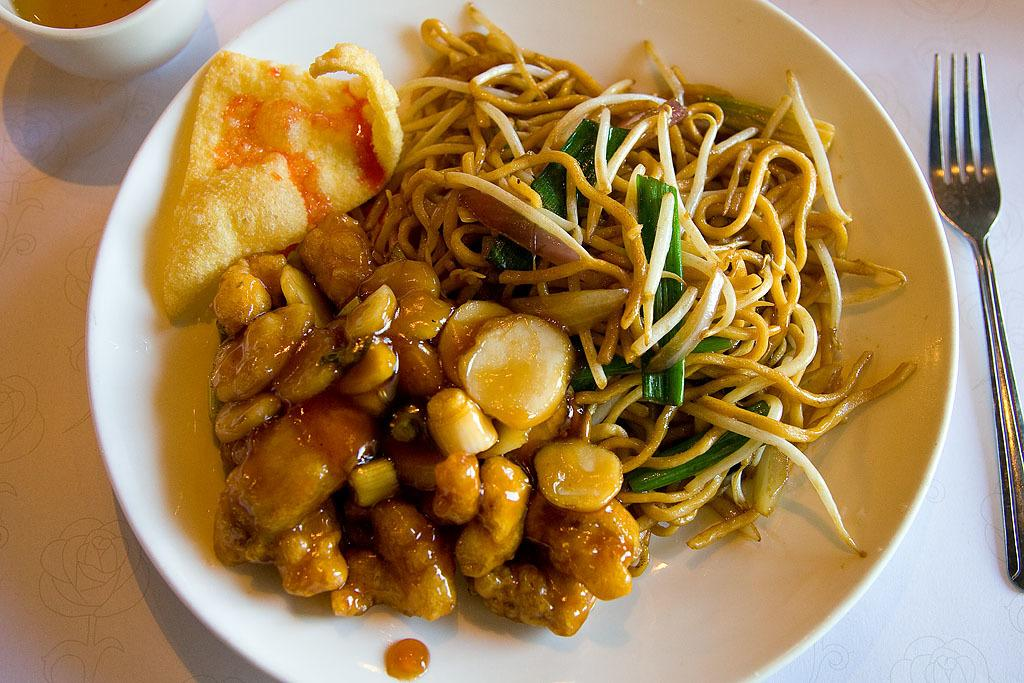What type of food is on the plate in the image? There is a chip, noodles, vegetable pieces, and curry on the plate. What color is the plate in the image? The plate is white in color. What utensil is present on the plate? There is a fork on the plate. What beverage is visible on the plate? There is a cup with tea on the plate. What type of truck is parked next to the plate in the image? There is no truck present in the image; it only features a plate of food, a fork, and a cup with tea. 